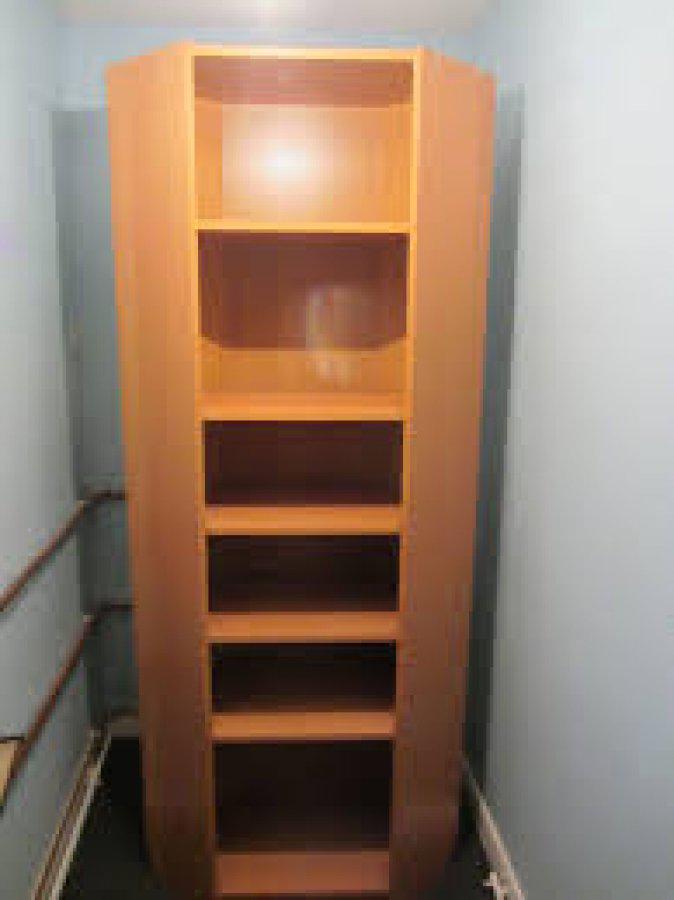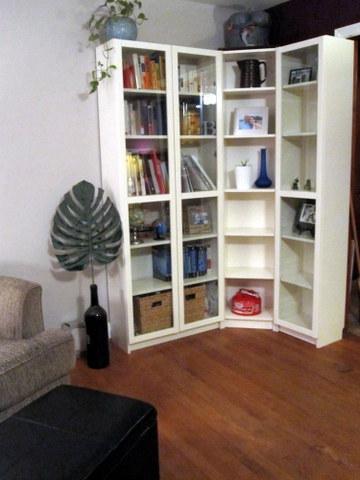The first image is the image on the left, the second image is the image on the right. Examine the images to the left and right. Is the description "A shelf unit consists of two tall, narrow shelves of equal size, placed at ninety degree angles to each other in the corner of a room." accurate? Answer yes or no. No. The first image is the image on the left, the second image is the image on the right. Considering the images on both sides, is "One image shows a completely empty white shelf while the other shows a shelf with contents, and all shelves are designed to fit in a corner." valid? Answer yes or no. No. 